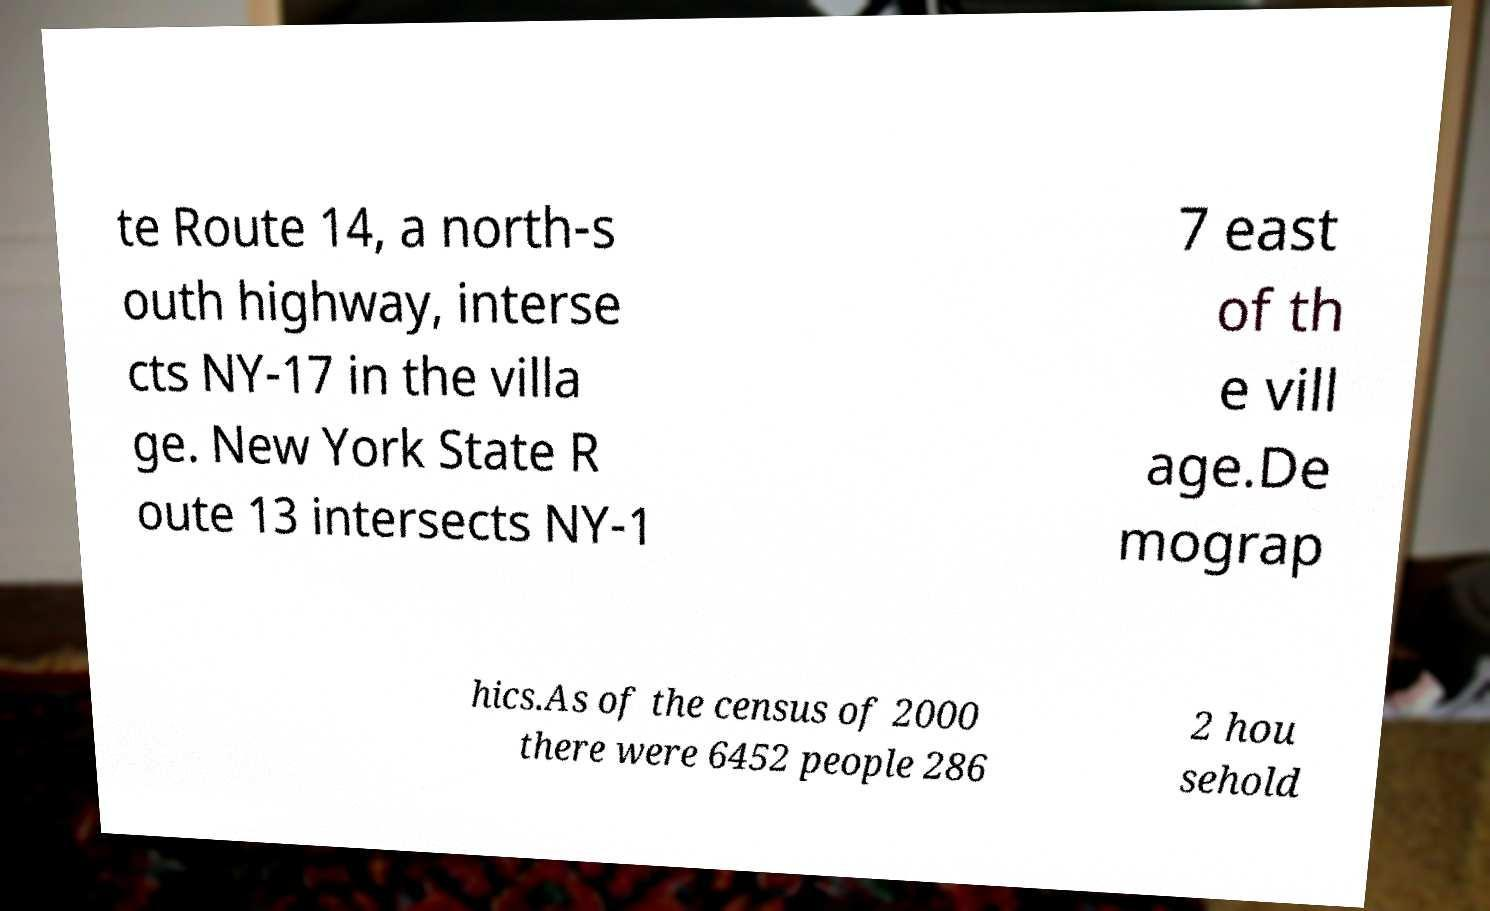Please read and relay the text visible in this image. What does it say? te Route 14, a north-s outh highway, interse cts NY-17 in the villa ge. New York State R oute 13 intersects NY-1 7 east of th e vill age.De mograp hics.As of the census of 2000 there were 6452 people 286 2 hou sehold 